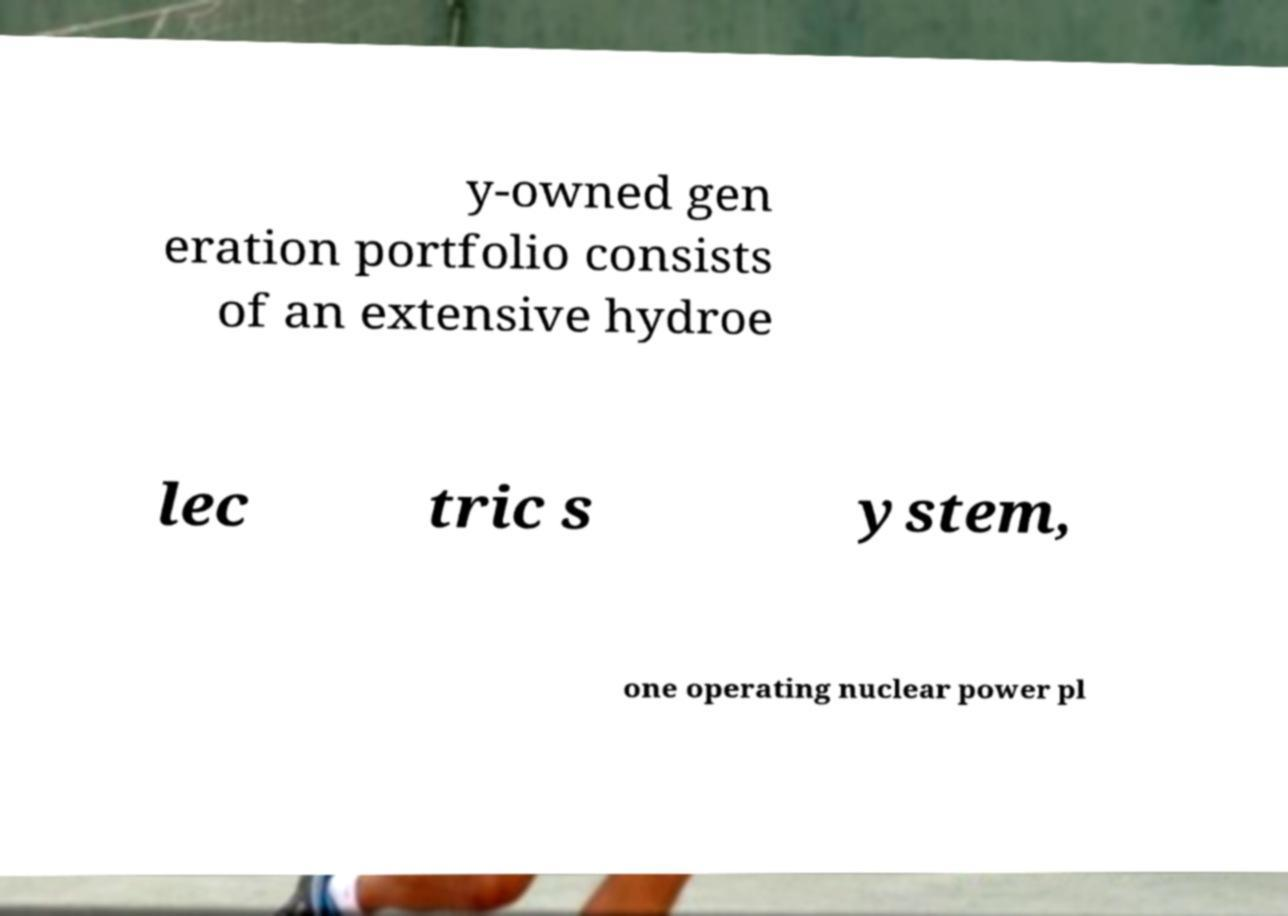Can you read and provide the text displayed in the image?This photo seems to have some interesting text. Can you extract and type it out for me? y-owned gen eration portfolio consists of an extensive hydroe lec tric s ystem, one operating nuclear power pl 